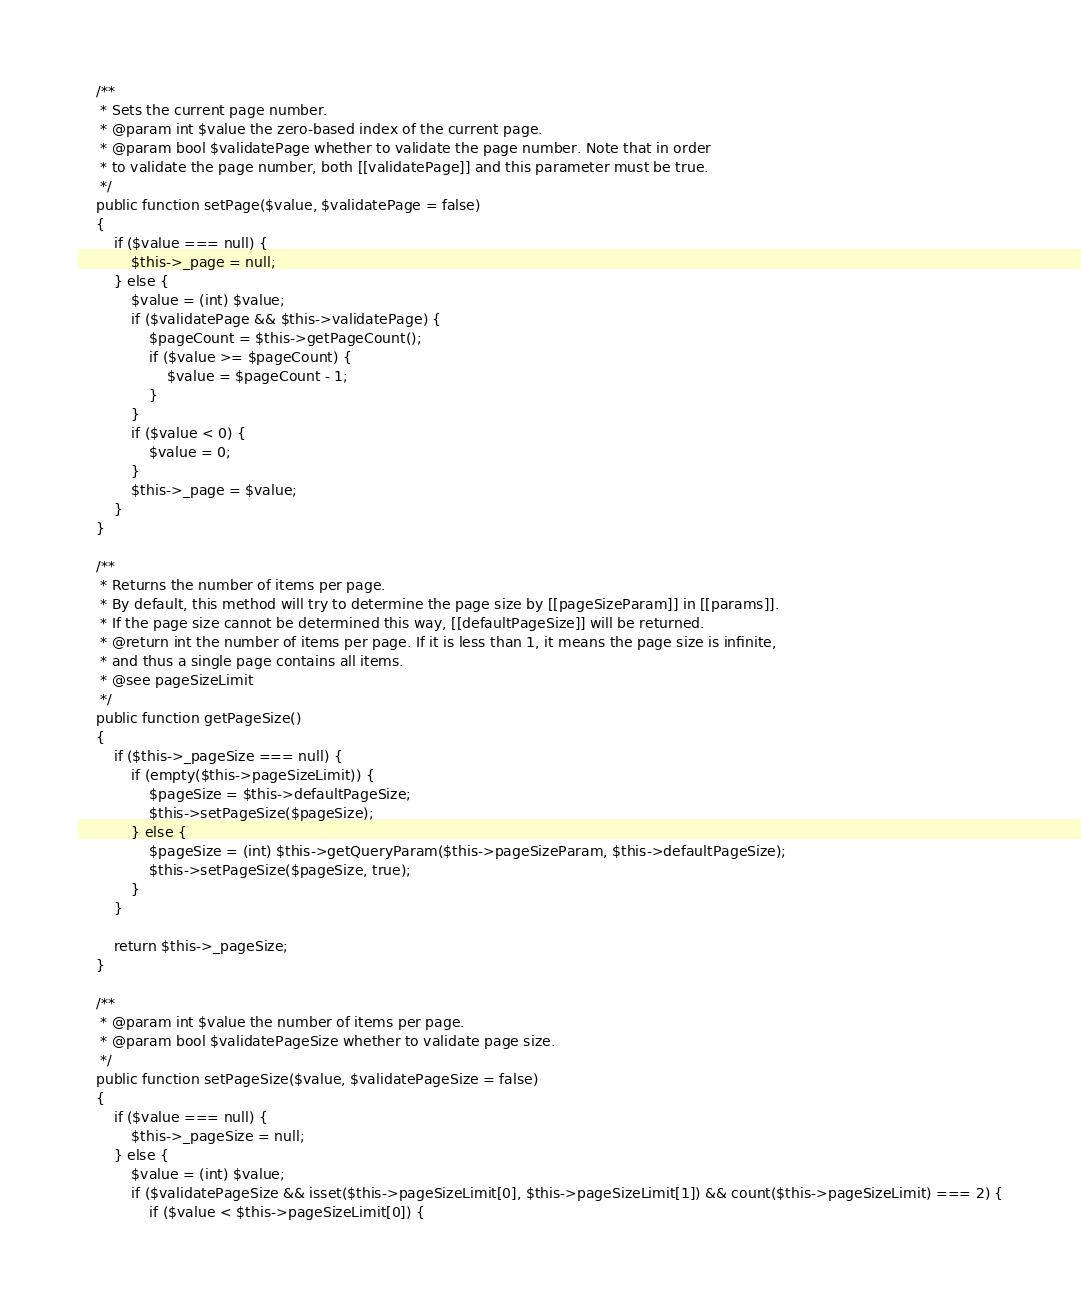Convert code to text. <code><loc_0><loc_0><loc_500><loc_500><_PHP_>
    /**
     * Sets the current page number.
     * @param int $value the zero-based index of the current page.
     * @param bool $validatePage whether to validate the page number. Note that in order
     * to validate the page number, both [[validatePage]] and this parameter must be true.
     */
    public function setPage($value, $validatePage = false)
    {
        if ($value === null) {
            $this->_page = null;
        } else {
            $value = (int) $value;
            if ($validatePage && $this->validatePage) {
                $pageCount = $this->getPageCount();
                if ($value >= $pageCount) {
                    $value = $pageCount - 1;
                }
            }
            if ($value < 0) {
                $value = 0;
            }
            $this->_page = $value;
        }
    }

    /**
     * Returns the number of items per page.
     * By default, this method will try to determine the page size by [[pageSizeParam]] in [[params]].
     * If the page size cannot be determined this way, [[defaultPageSize]] will be returned.
     * @return int the number of items per page. If it is less than 1, it means the page size is infinite,
     * and thus a single page contains all items.
     * @see pageSizeLimit
     */
    public function getPageSize()
    {
        if ($this->_pageSize === null) {
            if (empty($this->pageSizeLimit)) {
                $pageSize = $this->defaultPageSize;
                $this->setPageSize($pageSize);
            } else {
                $pageSize = (int) $this->getQueryParam($this->pageSizeParam, $this->defaultPageSize);
                $this->setPageSize($pageSize, true);
            }
        }

        return $this->_pageSize;
    }

    /**
     * @param int $value the number of items per page.
     * @param bool $validatePageSize whether to validate page size.
     */
    public function setPageSize($value, $validatePageSize = false)
    {
        if ($value === null) {
            $this->_pageSize = null;
        } else {
            $value = (int) $value;
            if ($validatePageSize && isset($this->pageSizeLimit[0], $this->pageSizeLimit[1]) && count($this->pageSizeLimit) === 2) {
                if ($value < $this->pageSizeLimit[0]) {</code> 